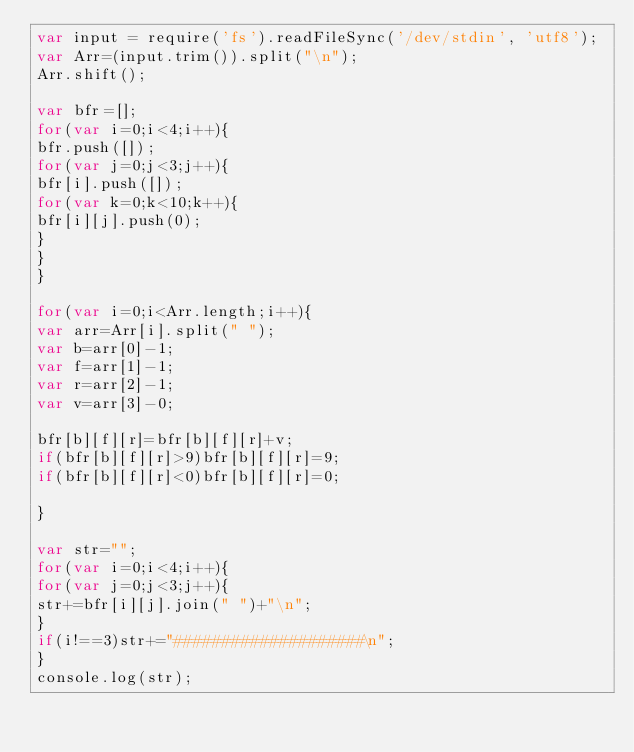Convert code to text. <code><loc_0><loc_0><loc_500><loc_500><_JavaScript_>var input = require('fs').readFileSync('/dev/stdin', 'utf8');
var Arr=(input.trim()).split("\n");
Arr.shift();

var bfr=[];
for(var i=0;i<4;i++){
bfr.push([]);
for(var j=0;j<3;j++){
bfr[i].push([]);
for(var k=0;k<10;k++){
bfr[i][j].push(0);
}
}
}

for(var i=0;i<Arr.length;i++){
var arr=Arr[i].split(" ");
var b=arr[0]-1;
var f=arr[1]-1;
var r=arr[2]-1;
var v=arr[3]-0;

bfr[b][f][r]=bfr[b][f][r]+v;
if(bfr[b][f][r]>9)bfr[b][f][r]=9;
if(bfr[b][f][r]<0)bfr[b][f][r]=0;

}

var str="";
for(var i=0;i<4;i++){
for(var j=0;j<3;j++){
str+=bfr[i][j].join(" ")+"\n";
}
if(i!==3)str+="####################\n";
}
console.log(str);</code> 